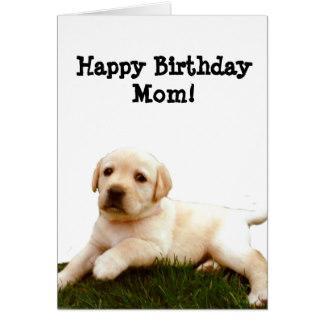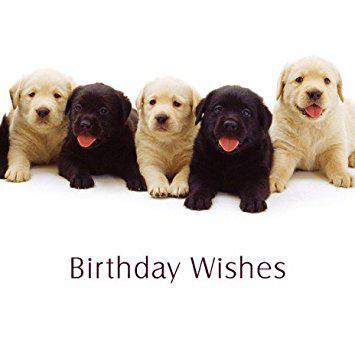The first image is the image on the left, the second image is the image on the right. Given the left and right images, does the statement "One image shows exactly two puppies, including a black one." hold true? Answer yes or no. No. The first image is the image on the left, the second image is the image on the right. Assess this claim about the two images: "there are five dogs in the image on the right.". Correct or not? Answer yes or no. Yes. 